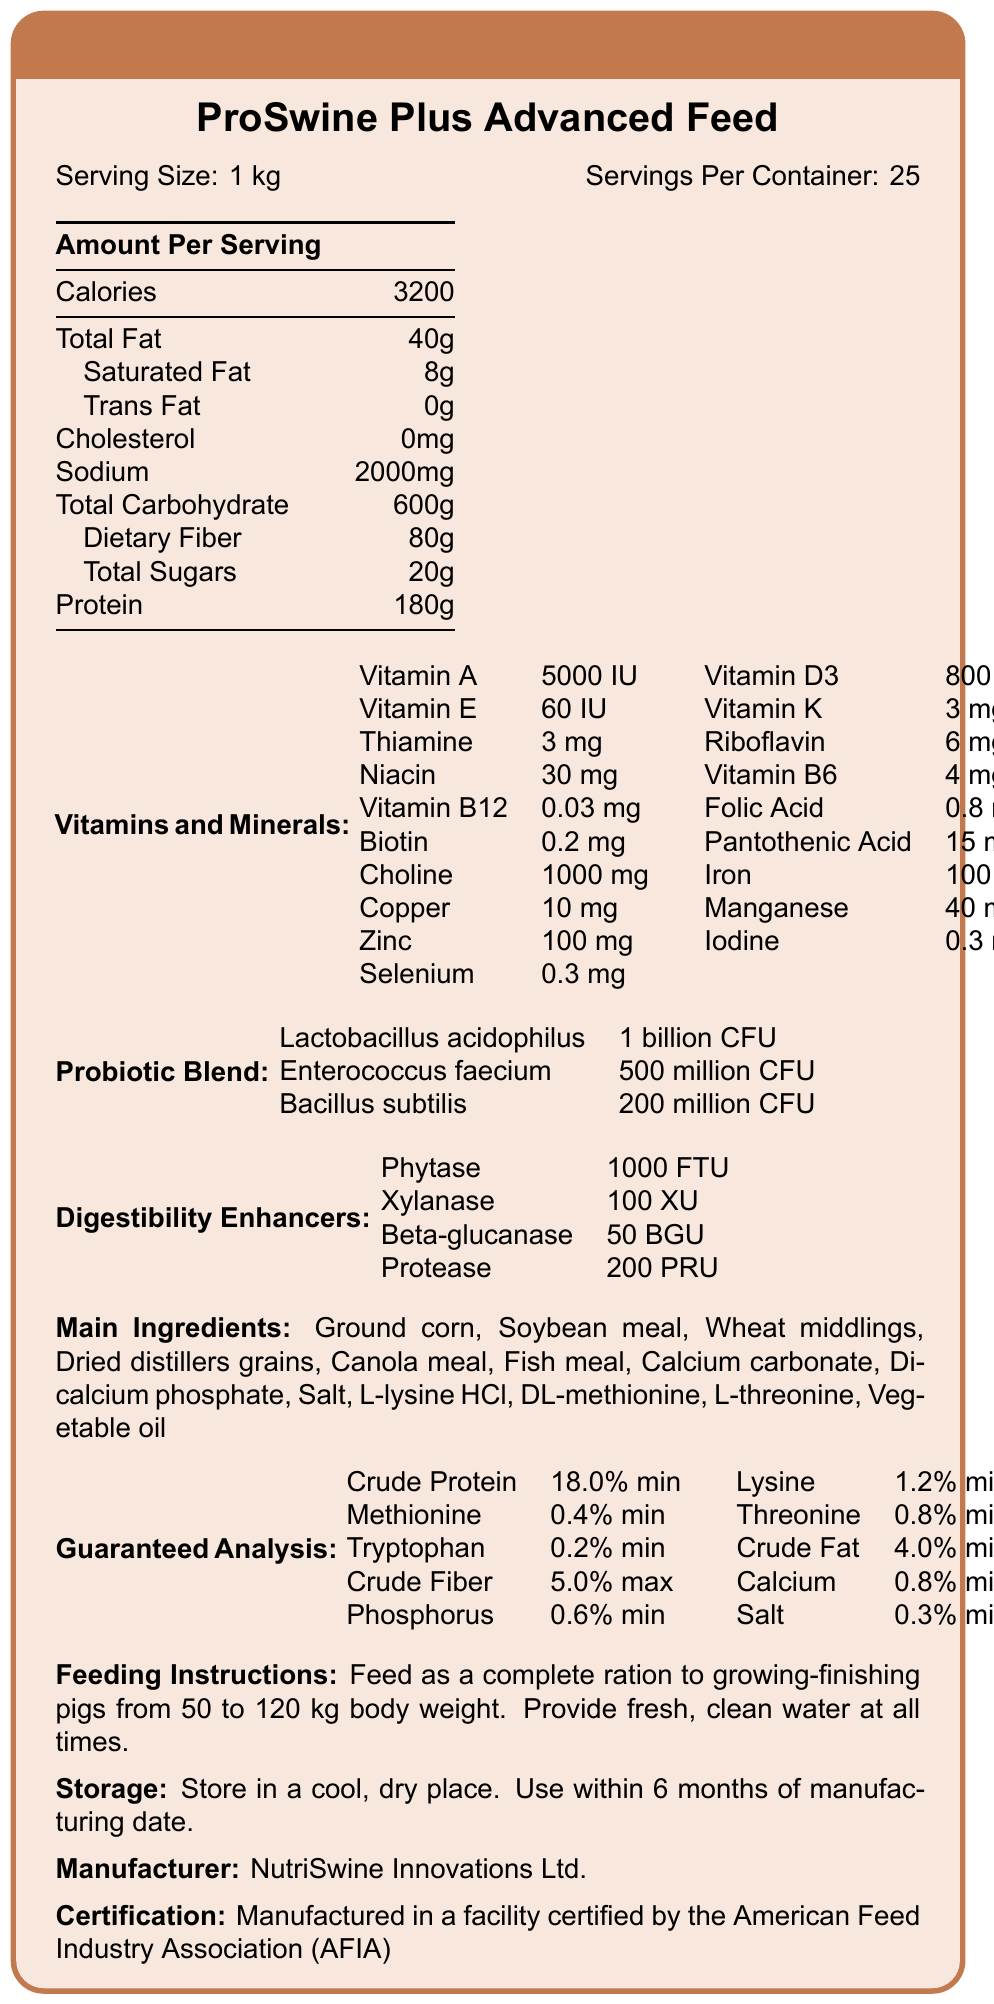When comparing the crude protein content to other nutrients listed under the guaranteed analysis, how does it rank? The crude protein content is the highest percentage listed under guaranteed analysis.
Answer: 18.0% min What is the recommended body weight range for pigs to consume this feed? The feeding instructions specify that this feed should be given to pigs from 50 to 120 kg body weight.
Answer: 50 to 120 kg How much sodium is there per serving? The nutrition facts section lists 2000 mg of sodium per serving.
Answer: 2000 mg Which probiotic strain has the highest CFU in the Probiotic Blend? Lactobacillus acidophilus is listed with 1 billion CFU, which is higher than Enterococcus faecium and Bacillus subtilis.
Answer: Lactobacillus acidophilus Is there any cholesterol in the ProSwine Plus Advanced Feed? The nutrition facts state that there is 0 mg of cholesterol per serving.
Answer: No What are the three primary enzymes included as digestibility enhancers? (Select all that apply) 
1. Phytase 
2. Xylanase 
3. Beta-glucanase 
4. Urease 
5. Cellulase The document lists Phytase, Xylanase, and Beta-glucanase as digestibility enhancers. Urease and Cellulase are not mentioned.
Answer: 1, 2, 3 Which company manufactures the ProSwine Plus Advanced Feed? 
A. Swine Nutrition Co.
B. Livestock Feed Corp.
C. NutriSwine Innovations Ltd. 
D. HealthyFeed Inc. NutriSwine Innovations Ltd. is the manufacturer listed.
Answer: C Based on the guaranteed analysis, what is the minimum crude fiber content? The crude fiber content is listed as 5.0% max, meaning it should not exceed this percentage.
Answer: 5.0% max Is the feed certified by any organization? The document states that the feed is manufactured in a facility certified by the American Feed Industry Association (AFIA).
Answer: Yes Describe the main idea of the document. The document is centered around providing a comprehensive overview of the nutritional composition and benefits of the ProSwine Plus Advanced Feed, aiming to inform livestock farmers about its suitability and effectiveness for swine health and growth.
Answer: This document is a nutrition facts label for the ProSwine Plus Advanced Feed. It provides detailed nutritional information, including calories, macronutrients, and vitamins/minerals per serving. It also highlights the probiotic blend and digestibility enhancers used in the feed, lists the main ingredients, specifies the guaranteed analysis of nutrient content, gives feeding instructions, storage guidelines, manufacturer details, and certification. Does the feed contain Vitamin B12? If yes, how much per serving? The vitamins and minerals section lists Vitamin B12 with a content of 0.03 mg per serving.
Answer: Yes, 0.03 mg What is the nutrient with the least amount among the guaranteed analysis parameters? The guaranteed analysis lists tryptophan as 0.2% min, which is the smallest value among the listed nutrients.
Answer: Tryptophan How much dietary fiber is included in each serving of the feed? The nutritional facts section includes a dietary fiber content of 80g per serving.
Answer: 80g Can you determine the exact cost per serving of the ProSwine Plus Advanced Feed from the information provided in the document? The document does not include any pricing details or cost information.
Answer: Not enough information 